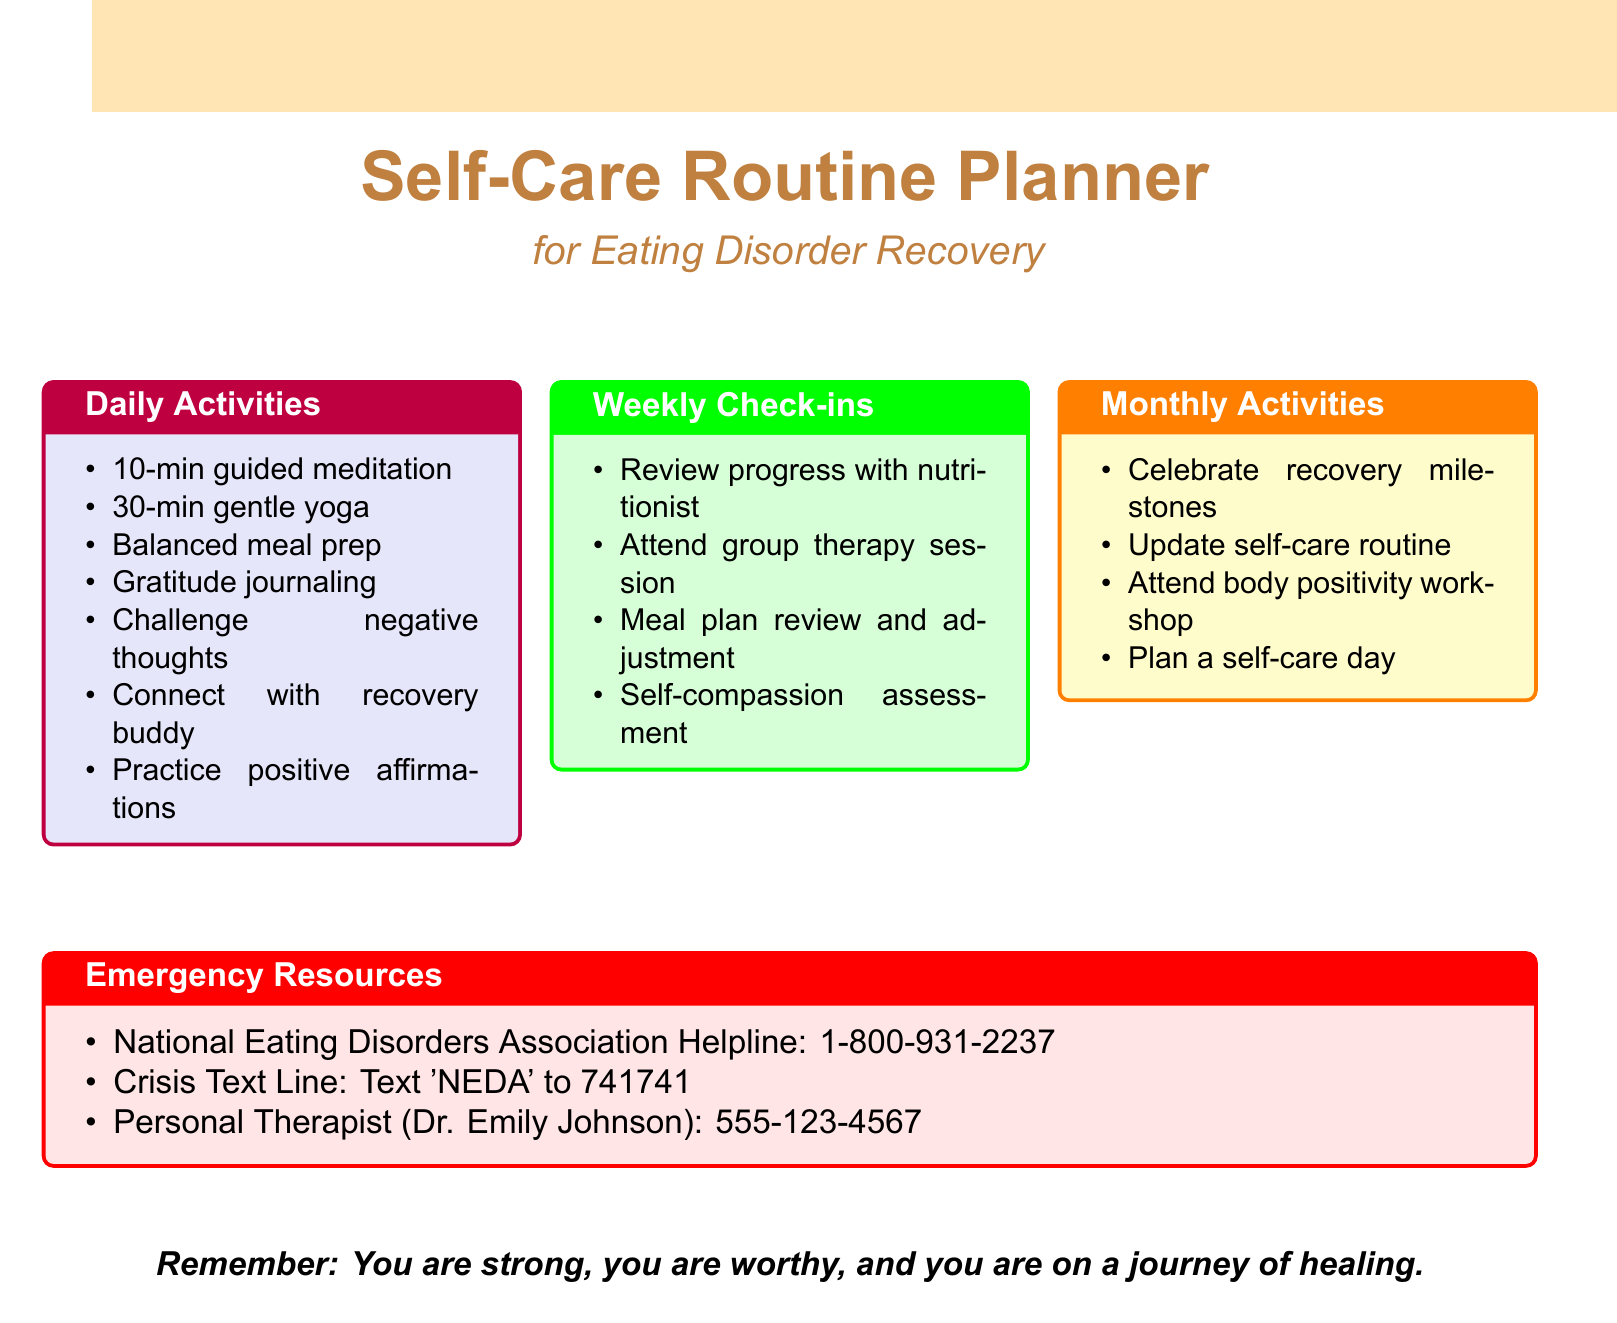What are the two activities under Mindfulness? The document lists "10-minute guided meditation using the Calm app" and "Body scan exercise" as Mindfulness activities.
Answer: 10-minute guided meditation using the Calm app, Body scan exercise How long is the gentle yoga session? The gentle yoga session is specified as lasting 30 minutes.
Answer: 30-minute Who is the personal therapist listed in the emergency resources? The document provides the name of the personal therapist as Dr. Emily Johnson.
Answer: Dr. Emily Johnson What kind of journal activity is included in Self-Expression? The document mentions "Write in a recovery journal" as a Self-Expression activity.
Answer: Write in a recovery journal What is scheduled as a bi-weekly activity? The document indicates "Schedule bi-weekly therapy sessions with Dr. Emily Johnson" as a bi-weekly activity.
Answer: Schedule bi-weekly therapy sessions with Dr. Emily Johnson What is the purpose of the monthly activities? The monthly activities are designed to celebrate recovery milestones and update self-care routines.
Answer: Celebrate recovery milestones, update self-care routine How many hours of sleep are recommended? The document recommends 8 hours of sleep with a consistent bedtime routine.
Answer: 8 hours What can you text to reach the Crisis Text Line? The document states to text 'NEDA' to contact the Crisis Text Line.
Answer: Text 'NEDA' What is the main focus of the planner? The planner emphasizes self-care activities that support eating disorder recovery.
Answer: Self-care activities for eating disorder recovery 